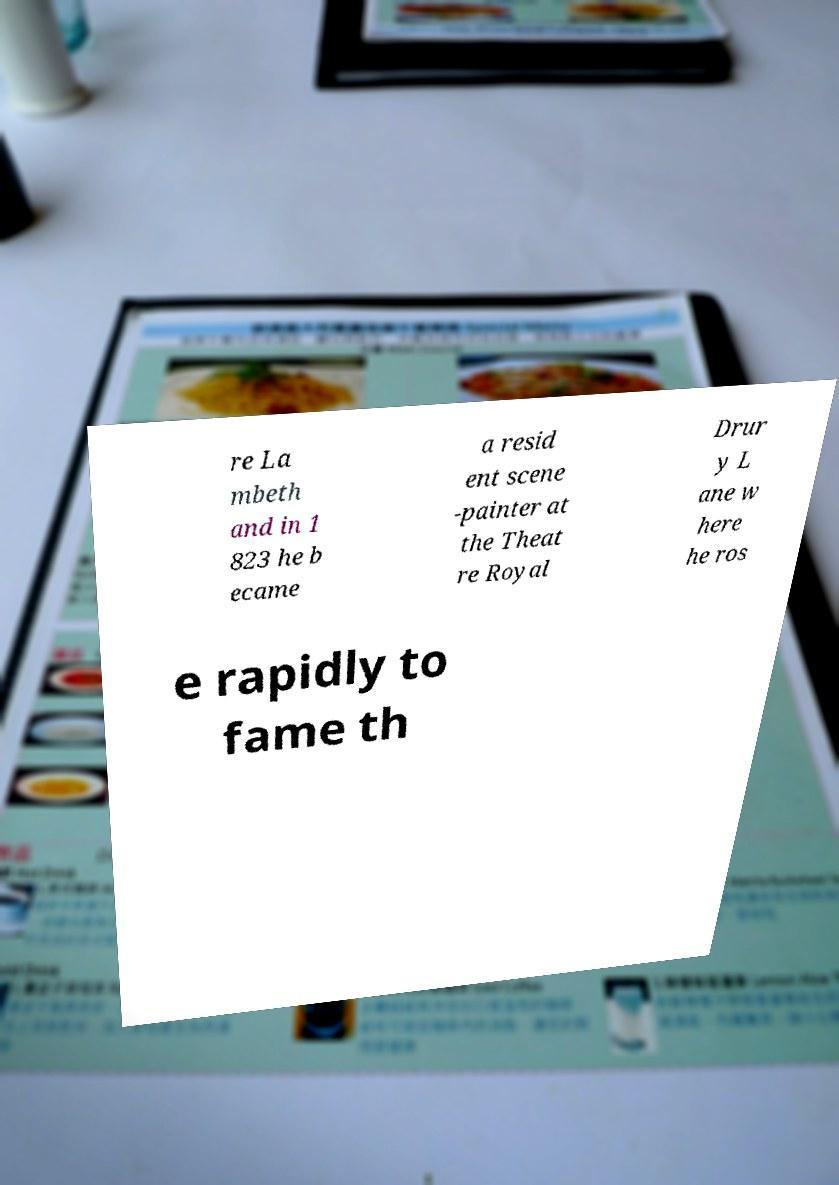For documentation purposes, I need the text within this image transcribed. Could you provide that? re La mbeth and in 1 823 he b ecame a resid ent scene -painter at the Theat re Royal Drur y L ane w here he ros e rapidly to fame th 